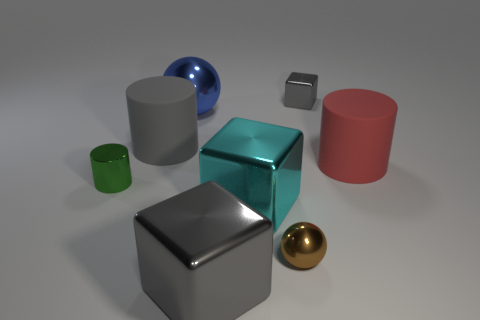Subtract all gray blocks. How many were subtracted if there are1gray blocks left? 1 Subtract all big matte cylinders. How many cylinders are left? 1 Add 1 gray metal blocks. How many objects exist? 9 Subtract all blocks. How many objects are left? 5 Subtract all gray blocks. How many blocks are left? 1 Subtract 2 cylinders. How many cylinders are left? 1 Subtract all purple spheres. Subtract all green cylinders. How many spheres are left? 2 Subtract all red cylinders. How many cyan cubes are left? 1 Subtract all yellow rubber spheres. Subtract all metal things. How many objects are left? 2 Add 6 large gray things. How many large gray things are left? 8 